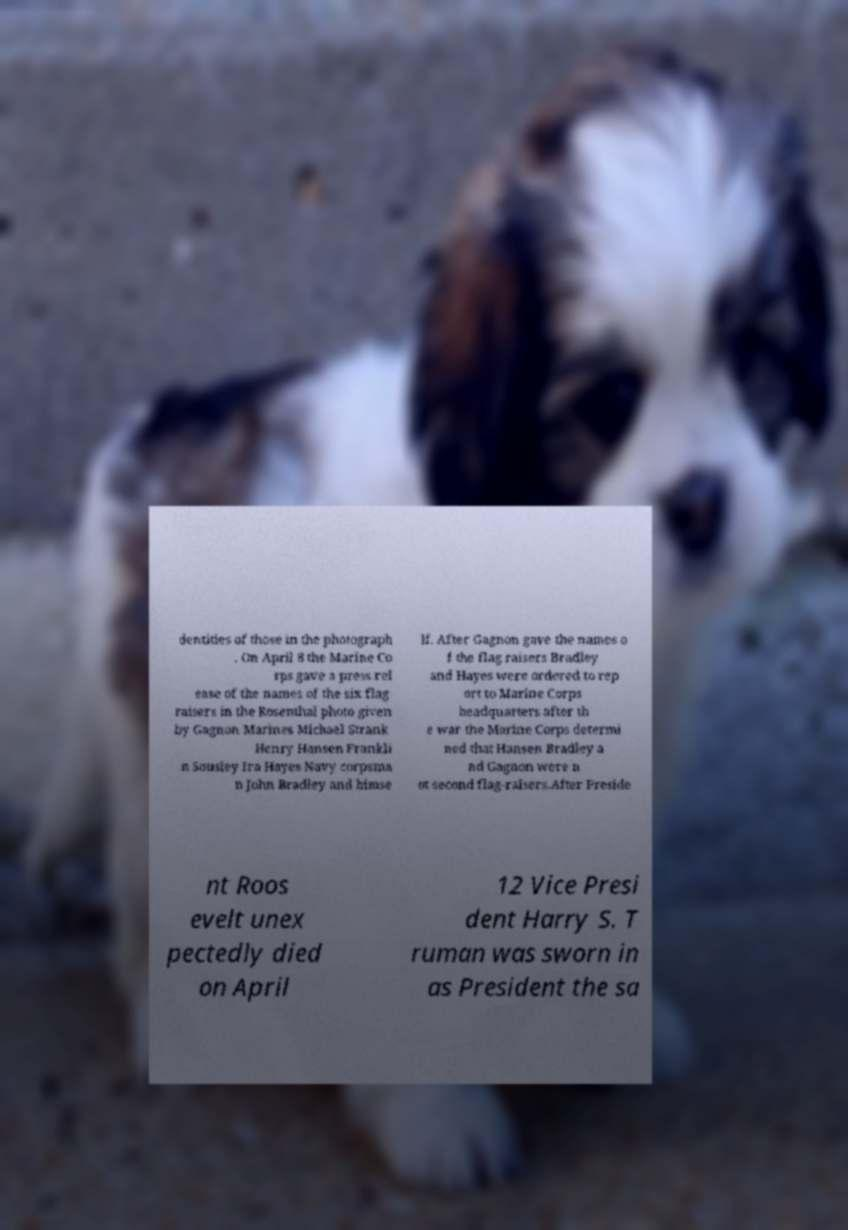Could you extract and type out the text from this image? dentities of those in the photograph . On April 8 the Marine Co rps gave a press rel ease of the names of the six flag raisers in the Rosenthal photo given by Gagnon Marines Michael Strank Henry Hansen Frankli n Sousley Ira Hayes Navy corpsma n John Bradley and himse lf. After Gagnon gave the names o f the flag raisers Bradley and Hayes were ordered to rep ort to Marine Corps headquarters after th e war the Marine Corps determi ned that Hansen Bradley a nd Gagnon were n ot second flag-raisers.After Preside nt Roos evelt unex pectedly died on April 12 Vice Presi dent Harry S. T ruman was sworn in as President the sa 